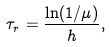<formula> <loc_0><loc_0><loc_500><loc_500>\tau _ { r } = \frac { \ln ( 1 / \mu ) } { h } ,</formula> 